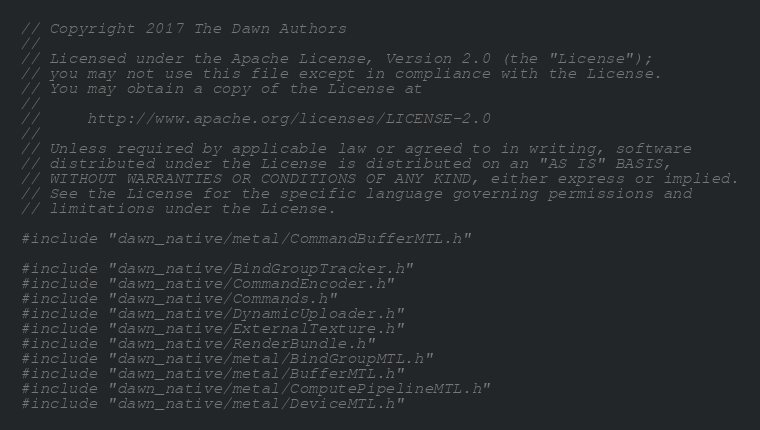<code> <loc_0><loc_0><loc_500><loc_500><_ObjectiveC_>// Copyright 2017 The Dawn Authors
//
// Licensed under the Apache License, Version 2.0 (the "License");
// you may not use this file except in compliance with the License.
// You may obtain a copy of the License at
//
//     http://www.apache.org/licenses/LICENSE-2.0
//
// Unless required by applicable law or agreed to in writing, software
// distributed under the License is distributed on an "AS IS" BASIS,
// WITHOUT WARRANTIES OR CONDITIONS OF ANY KIND, either express or implied.
// See the License for the specific language governing permissions and
// limitations under the License.

#include "dawn_native/metal/CommandBufferMTL.h"

#include "dawn_native/BindGroupTracker.h"
#include "dawn_native/CommandEncoder.h"
#include "dawn_native/Commands.h"
#include "dawn_native/DynamicUploader.h"
#include "dawn_native/ExternalTexture.h"
#include "dawn_native/RenderBundle.h"
#include "dawn_native/metal/BindGroupMTL.h"
#include "dawn_native/metal/BufferMTL.h"
#include "dawn_native/metal/ComputePipelineMTL.h"
#include "dawn_native/metal/DeviceMTL.h"</code> 